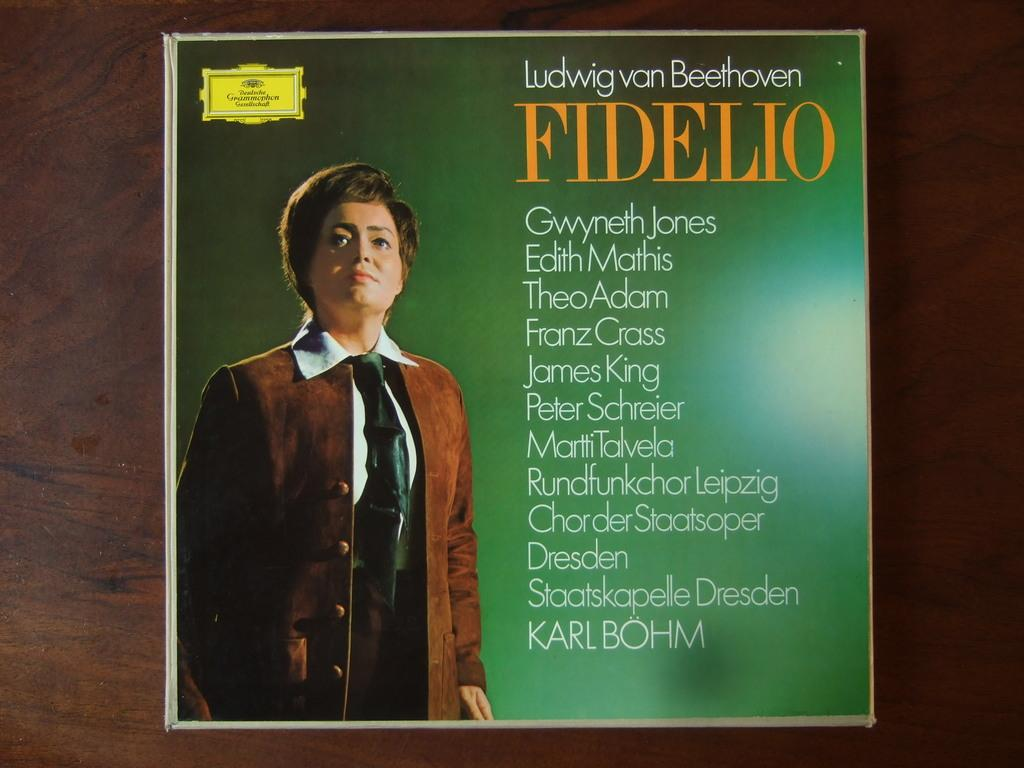<image>
Create a compact narrative representing the image presented. An album of Beethoven music includes the artist Theo Adams. 